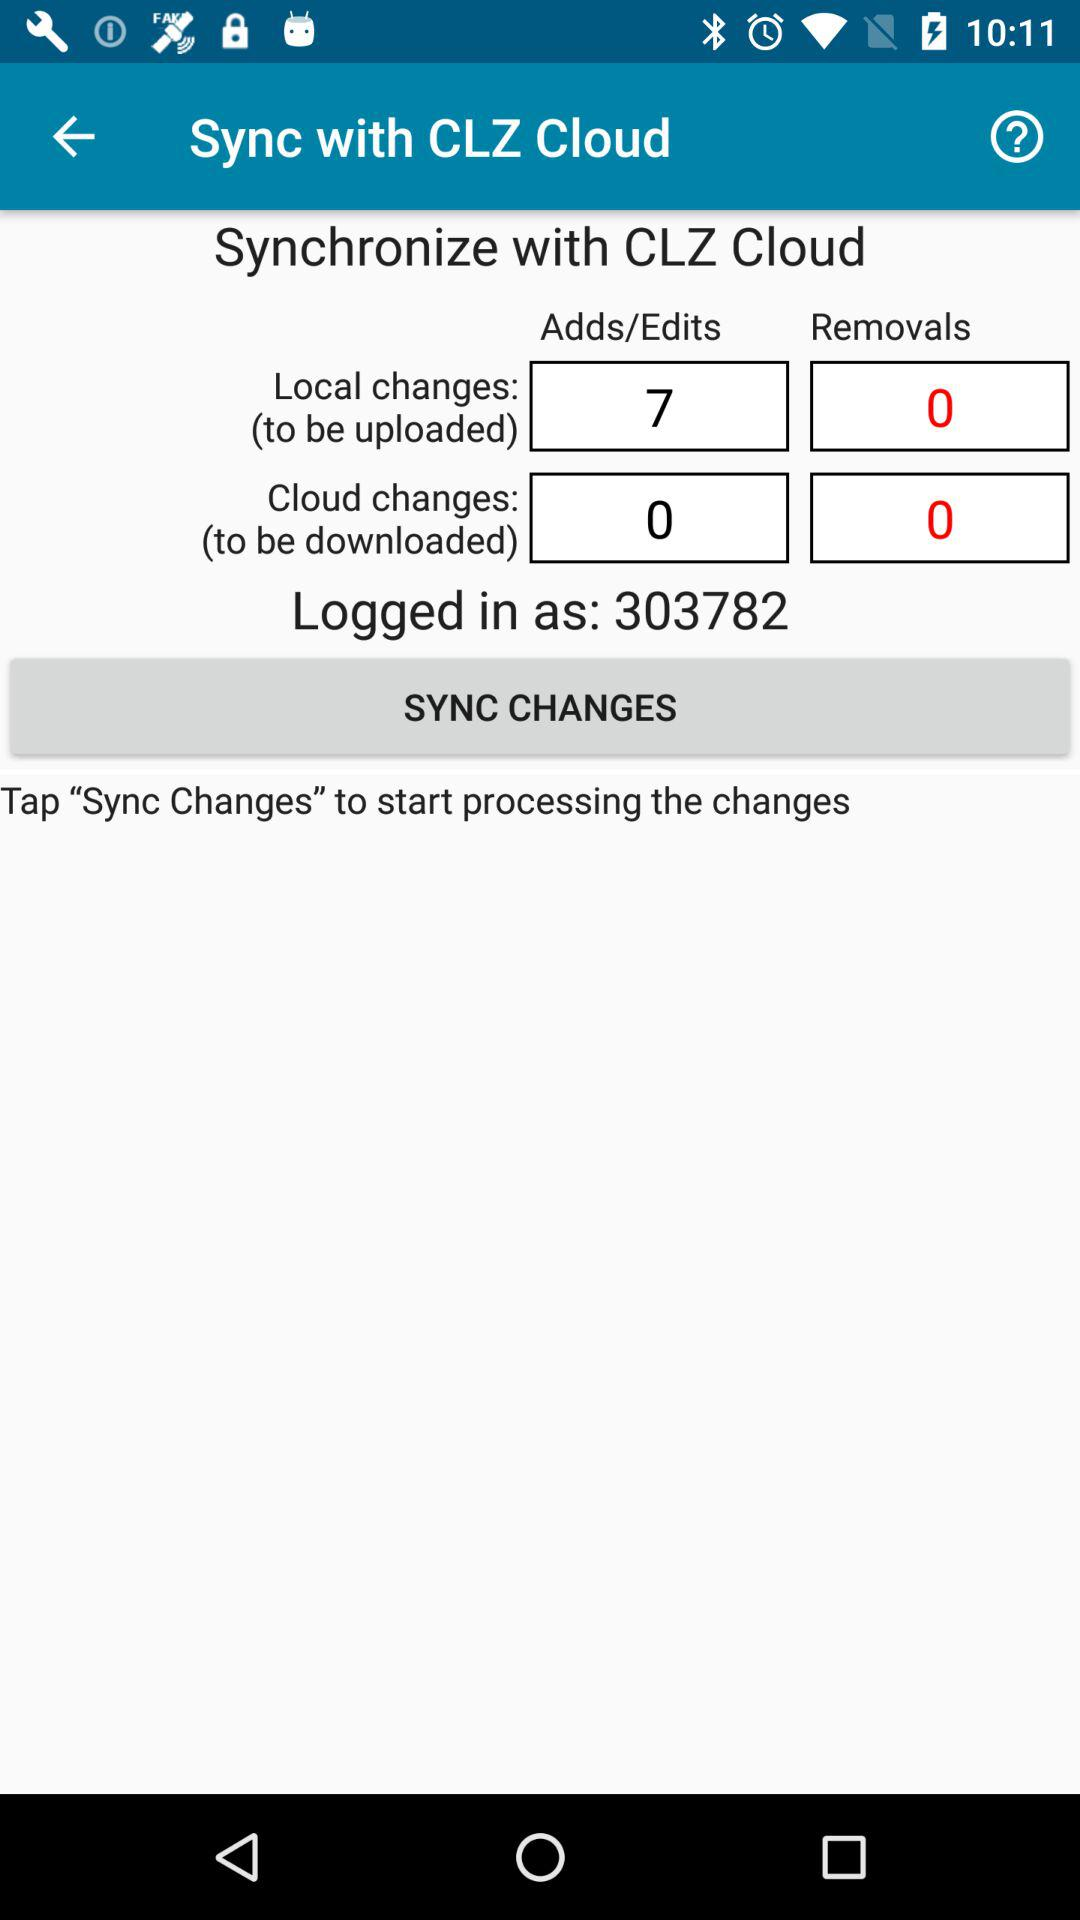What is the count of adds for local changes (to be uploaded)? The count of adds for local changes (to be uploaded) is 7. 